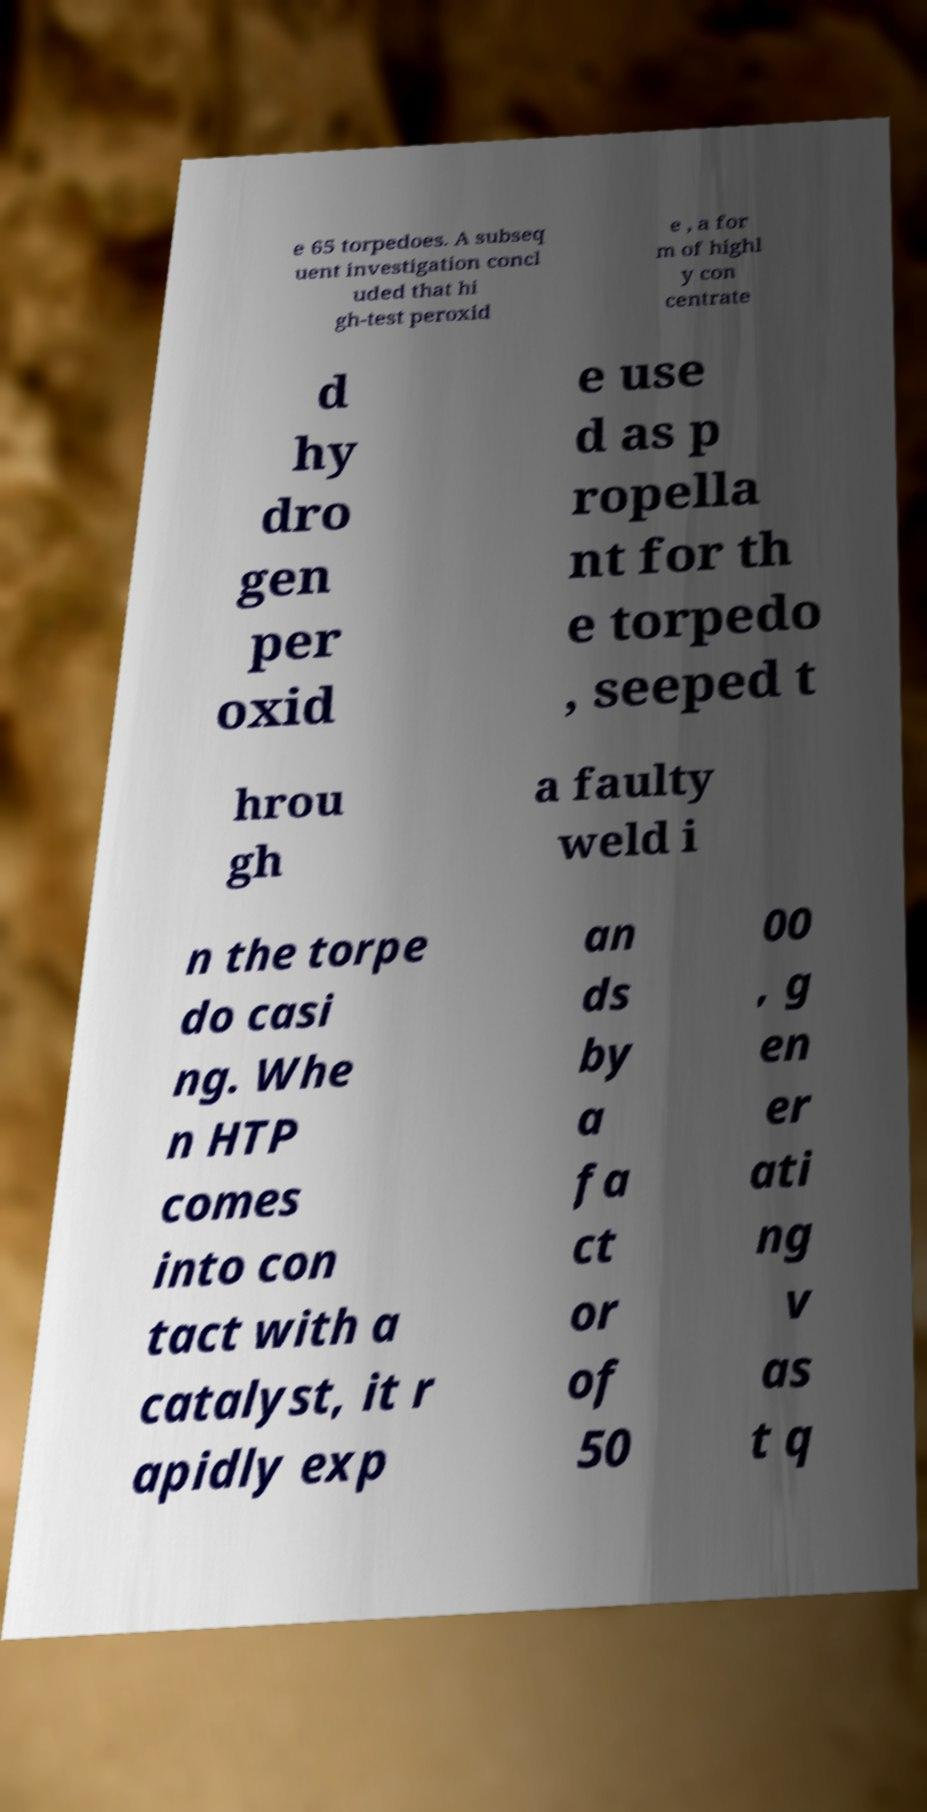Can you read and provide the text displayed in the image?This photo seems to have some interesting text. Can you extract and type it out for me? e 65 torpedoes. A subseq uent investigation concl uded that hi gh-test peroxid e , a for m of highl y con centrate d hy dro gen per oxid e use d as p ropella nt for th e torpedo , seeped t hrou gh a faulty weld i n the torpe do casi ng. Whe n HTP comes into con tact with a catalyst, it r apidly exp an ds by a fa ct or of 50 00 , g en er ati ng v as t q 